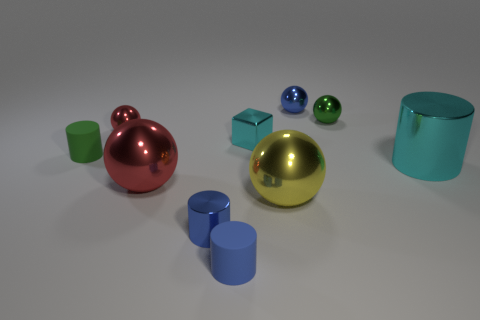Subtract all blue spheres. How many spheres are left? 4 Subtract 1 balls. How many balls are left? 4 Subtract all tiny green spheres. How many spheres are left? 4 Subtract all brown spheres. Subtract all cyan blocks. How many spheres are left? 5 Subtract all cylinders. How many objects are left? 6 Subtract all tiny brown rubber balls. Subtract all big red metal objects. How many objects are left? 9 Add 2 big yellow balls. How many big yellow balls are left? 3 Add 2 small cylinders. How many small cylinders exist? 5 Subtract 0 cyan balls. How many objects are left? 10 